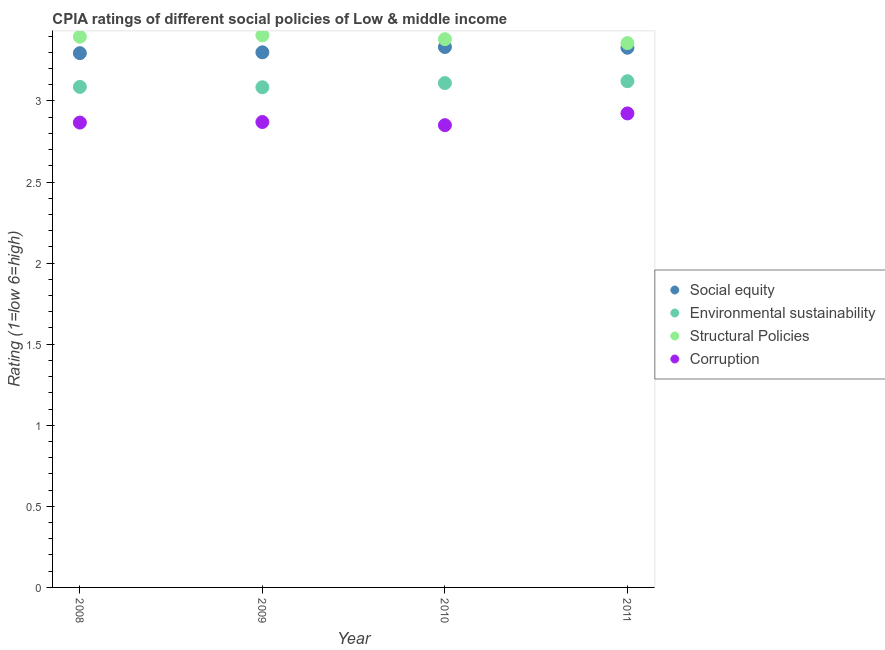How many different coloured dotlines are there?
Keep it short and to the point. 4. What is the cpia rating of corruption in 2009?
Provide a short and direct response. 2.87. Across all years, what is the maximum cpia rating of environmental sustainability?
Provide a succinct answer. 3.12. Across all years, what is the minimum cpia rating of corruption?
Keep it short and to the point. 2.85. What is the total cpia rating of structural policies in the graph?
Your answer should be compact. 13.54. What is the difference between the cpia rating of structural policies in 2009 and that in 2011?
Keep it short and to the point. 0.05. What is the difference between the cpia rating of environmental sustainability in 2010 and the cpia rating of corruption in 2008?
Your response must be concise. 0.24. What is the average cpia rating of structural policies per year?
Give a very brief answer. 3.38. In the year 2008, what is the difference between the cpia rating of structural policies and cpia rating of corruption?
Offer a very short reply. 0.53. What is the ratio of the cpia rating of social equity in 2010 to that in 2011?
Ensure brevity in your answer.  1. Is the cpia rating of social equity in 2009 less than that in 2011?
Your answer should be very brief. Yes. Is the difference between the cpia rating of structural policies in 2008 and 2011 greater than the difference between the cpia rating of social equity in 2008 and 2011?
Your answer should be compact. Yes. What is the difference between the highest and the second highest cpia rating of environmental sustainability?
Offer a very short reply. 0.01. What is the difference between the highest and the lowest cpia rating of environmental sustainability?
Provide a short and direct response. 0.04. Does the cpia rating of structural policies monotonically increase over the years?
Offer a terse response. No. Is the cpia rating of social equity strictly greater than the cpia rating of structural policies over the years?
Give a very brief answer. No. Is the cpia rating of structural policies strictly less than the cpia rating of corruption over the years?
Make the answer very short. No. How many dotlines are there?
Keep it short and to the point. 4. How many years are there in the graph?
Your response must be concise. 4. Are the values on the major ticks of Y-axis written in scientific E-notation?
Offer a very short reply. No. How are the legend labels stacked?
Give a very brief answer. Vertical. What is the title of the graph?
Ensure brevity in your answer.  CPIA ratings of different social policies of Low & middle income. Does "Revenue mobilization" appear as one of the legend labels in the graph?
Offer a terse response. No. What is the Rating (1=low 6=high) of Social equity in 2008?
Provide a succinct answer. 3.29. What is the Rating (1=low 6=high) of Environmental sustainability in 2008?
Provide a succinct answer. 3.09. What is the Rating (1=low 6=high) in Structural Policies in 2008?
Provide a short and direct response. 3.4. What is the Rating (1=low 6=high) of Corruption in 2008?
Keep it short and to the point. 2.87. What is the Rating (1=low 6=high) in Environmental sustainability in 2009?
Make the answer very short. 3.08. What is the Rating (1=low 6=high) in Structural Policies in 2009?
Offer a terse response. 3.4. What is the Rating (1=low 6=high) in Corruption in 2009?
Offer a terse response. 2.87. What is the Rating (1=low 6=high) in Social equity in 2010?
Offer a very short reply. 3.33. What is the Rating (1=low 6=high) of Environmental sustainability in 2010?
Offer a terse response. 3.11. What is the Rating (1=low 6=high) of Structural Policies in 2010?
Keep it short and to the point. 3.38. What is the Rating (1=low 6=high) in Corruption in 2010?
Your response must be concise. 2.85. What is the Rating (1=low 6=high) in Social equity in 2011?
Provide a short and direct response. 3.33. What is the Rating (1=low 6=high) of Environmental sustainability in 2011?
Your answer should be very brief. 3.12. What is the Rating (1=low 6=high) of Structural Policies in 2011?
Provide a short and direct response. 3.36. What is the Rating (1=low 6=high) of Corruption in 2011?
Offer a very short reply. 2.92. Across all years, what is the maximum Rating (1=low 6=high) in Social equity?
Keep it short and to the point. 3.33. Across all years, what is the maximum Rating (1=low 6=high) of Environmental sustainability?
Your answer should be very brief. 3.12. Across all years, what is the maximum Rating (1=low 6=high) in Structural Policies?
Your answer should be very brief. 3.4. Across all years, what is the maximum Rating (1=low 6=high) in Corruption?
Offer a very short reply. 2.92. Across all years, what is the minimum Rating (1=low 6=high) in Social equity?
Offer a very short reply. 3.29. Across all years, what is the minimum Rating (1=low 6=high) in Environmental sustainability?
Offer a terse response. 3.08. Across all years, what is the minimum Rating (1=low 6=high) in Structural Policies?
Make the answer very short. 3.36. Across all years, what is the minimum Rating (1=low 6=high) in Corruption?
Offer a terse response. 2.85. What is the total Rating (1=low 6=high) of Social equity in the graph?
Offer a terse response. 13.26. What is the total Rating (1=low 6=high) of Environmental sustainability in the graph?
Your answer should be compact. 12.4. What is the total Rating (1=low 6=high) of Structural Policies in the graph?
Make the answer very short. 13.54. What is the total Rating (1=low 6=high) of Corruption in the graph?
Provide a succinct answer. 11.51. What is the difference between the Rating (1=low 6=high) of Social equity in 2008 and that in 2009?
Give a very brief answer. -0.01. What is the difference between the Rating (1=low 6=high) in Environmental sustainability in 2008 and that in 2009?
Provide a succinct answer. 0. What is the difference between the Rating (1=low 6=high) of Structural Policies in 2008 and that in 2009?
Keep it short and to the point. -0.01. What is the difference between the Rating (1=low 6=high) in Corruption in 2008 and that in 2009?
Your answer should be very brief. -0. What is the difference between the Rating (1=low 6=high) of Social equity in 2008 and that in 2010?
Offer a terse response. -0.04. What is the difference between the Rating (1=low 6=high) of Environmental sustainability in 2008 and that in 2010?
Your response must be concise. -0.02. What is the difference between the Rating (1=low 6=high) in Structural Policies in 2008 and that in 2010?
Make the answer very short. 0.01. What is the difference between the Rating (1=low 6=high) in Corruption in 2008 and that in 2010?
Provide a short and direct response. 0.02. What is the difference between the Rating (1=low 6=high) of Social equity in 2008 and that in 2011?
Offer a terse response. -0.03. What is the difference between the Rating (1=low 6=high) of Environmental sustainability in 2008 and that in 2011?
Your response must be concise. -0.04. What is the difference between the Rating (1=low 6=high) in Structural Policies in 2008 and that in 2011?
Provide a short and direct response. 0.04. What is the difference between the Rating (1=low 6=high) in Corruption in 2008 and that in 2011?
Ensure brevity in your answer.  -0.06. What is the difference between the Rating (1=low 6=high) in Social equity in 2009 and that in 2010?
Your answer should be very brief. -0.03. What is the difference between the Rating (1=low 6=high) of Environmental sustainability in 2009 and that in 2010?
Ensure brevity in your answer.  -0.03. What is the difference between the Rating (1=low 6=high) in Structural Policies in 2009 and that in 2010?
Offer a very short reply. 0.02. What is the difference between the Rating (1=low 6=high) in Corruption in 2009 and that in 2010?
Ensure brevity in your answer.  0.02. What is the difference between the Rating (1=low 6=high) of Social equity in 2009 and that in 2011?
Keep it short and to the point. -0.03. What is the difference between the Rating (1=low 6=high) in Environmental sustainability in 2009 and that in 2011?
Keep it short and to the point. -0.04. What is the difference between the Rating (1=low 6=high) of Structural Policies in 2009 and that in 2011?
Give a very brief answer. 0.05. What is the difference between the Rating (1=low 6=high) in Corruption in 2009 and that in 2011?
Your answer should be very brief. -0.05. What is the difference between the Rating (1=low 6=high) of Social equity in 2010 and that in 2011?
Your answer should be very brief. 0. What is the difference between the Rating (1=low 6=high) of Environmental sustainability in 2010 and that in 2011?
Offer a terse response. -0.01. What is the difference between the Rating (1=low 6=high) in Structural Policies in 2010 and that in 2011?
Provide a short and direct response. 0.02. What is the difference between the Rating (1=low 6=high) of Corruption in 2010 and that in 2011?
Offer a very short reply. -0.07. What is the difference between the Rating (1=low 6=high) in Social equity in 2008 and the Rating (1=low 6=high) in Environmental sustainability in 2009?
Keep it short and to the point. 0.21. What is the difference between the Rating (1=low 6=high) in Social equity in 2008 and the Rating (1=low 6=high) in Structural Policies in 2009?
Your answer should be very brief. -0.11. What is the difference between the Rating (1=low 6=high) in Social equity in 2008 and the Rating (1=low 6=high) in Corruption in 2009?
Make the answer very short. 0.42. What is the difference between the Rating (1=low 6=high) in Environmental sustainability in 2008 and the Rating (1=low 6=high) in Structural Policies in 2009?
Your answer should be very brief. -0.32. What is the difference between the Rating (1=low 6=high) in Environmental sustainability in 2008 and the Rating (1=low 6=high) in Corruption in 2009?
Provide a succinct answer. 0.22. What is the difference between the Rating (1=low 6=high) in Structural Policies in 2008 and the Rating (1=low 6=high) in Corruption in 2009?
Provide a succinct answer. 0.53. What is the difference between the Rating (1=low 6=high) in Social equity in 2008 and the Rating (1=low 6=high) in Environmental sustainability in 2010?
Ensure brevity in your answer.  0.18. What is the difference between the Rating (1=low 6=high) of Social equity in 2008 and the Rating (1=low 6=high) of Structural Policies in 2010?
Give a very brief answer. -0.09. What is the difference between the Rating (1=low 6=high) in Social equity in 2008 and the Rating (1=low 6=high) in Corruption in 2010?
Offer a terse response. 0.44. What is the difference between the Rating (1=low 6=high) of Environmental sustainability in 2008 and the Rating (1=low 6=high) of Structural Policies in 2010?
Keep it short and to the point. -0.29. What is the difference between the Rating (1=low 6=high) of Environmental sustainability in 2008 and the Rating (1=low 6=high) of Corruption in 2010?
Give a very brief answer. 0.24. What is the difference between the Rating (1=low 6=high) of Structural Policies in 2008 and the Rating (1=low 6=high) of Corruption in 2010?
Keep it short and to the point. 0.55. What is the difference between the Rating (1=low 6=high) of Social equity in 2008 and the Rating (1=low 6=high) of Environmental sustainability in 2011?
Offer a terse response. 0.17. What is the difference between the Rating (1=low 6=high) of Social equity in 2008 and the Rating (1=low 6=high) of Structural Policies in 2011?
Keep it short and to the point. -0.06. What is the difference between the Rating (1=low 6=high) in Social equity in 2008 and the Rating (1=low 6=high) in Corruption in 2011?
Offer a very short reply. 0.37. What is the difference between the Rating (1=low 6=high) in Environmental sustainability in 2008 and the Rating (1=low 6=high) in Structural Policies in 2011?
Provide a short and direct response. -0.27. What is the difference between the Rating (1=low 6=high) in Environmental sustainability in 2008 and the Rating (1=low 6=high) in Corruption in 2011?
Offer a terse response. 0.16. What is the difference between the Rating (1=low 6=high) in Structural Policies in 2008 and the Rating (1=low 6=high) in Corruption in 2011?
Offer a very short reply. 0.47. What is the difference between the Rating (1=low 6=high) of Social equity in 2009 and the Rating (1=low 6=high) of Environmental sustainability in 2010?
Your response must be concise. 0.19. What is the difference between the Rating (1=low 6=high) of Social equity in 2009 and the Rating (1=low 6=high) of Structural Policies in 2010?
Provide a short and direct response. -0.08. What is the difference between the Rating (1=low 6=high) of Social equity in 2009 and the Rating (1=low 6=high) of Corruption in 2010?
Ensure brevity in your answer.  0.45. What is the difference between the Rating (1=low 6=high) of Environmental sustainability in 2009 and the Rating (1=low 6=high) of Structural Policies in 2010?
Provide a succinct answer. -0.3. What is the difference between the Rating (1=low 6=high) of Environmental sustainability in 2009 and the Rating (1=low 6=high) of Corruption in 2010?
Keep it short and to the point. 0.23. What is the difference between the Rating (1=low 6=high) of Structural Policies in 2009 and the Rating (1=low 6=high) of Corruption in 2010?
Offer a terse response. 0.55. What is the difference between the Rating (1=low 6=high) in Social equity in 2009 and the Rating (1=low 6=high) in Environmental sustainability in 2011?
Your answer should be very brief. 0.18. What is the difference between the Rating (1=low 6=high) of Social equity in 2009 and the Rating (1=low 6=high) of Structural Policies in 2011?
Offer a very short reply. -0.06. What is the difference between the Rating (1=low 6=high) in Social equity in 2009 and the Rating (1=low 6=high) in Corruption in 2011?
Provide a short and direct response. 0.38. What is the difference between the Rating (1=low 6=high) of Environmental sustainability in 2009 and the Rating (1=low 6=high) of Structural Policies in 2011?
Your answer should be very brief. -0.27. What is the difference between the Rating (1=low 6=high) in Environmental sustainability in 2009 and the Rating (1=low 6=high) in Corruption in 2011?
Keep it short and to the point. 0.16. What is the difference between the Rating (1=low 6=high) of Structural Policies in 2009 and the Rating (1=low 6=high) of Corruption in 2011?
Ensure brevity in your answer.  0.48. What is the difference between the Rating (1=low 6=high) of Social equity in 2010 and the Rating (1=low 6=high) of Environmental sustainability in 2011?
Keep it short and to the point. 0.21. What is the difference between the Rating (1=low 6=high) in Social equity in 2010 and the Rating (1=low 6=high) in Structural Policies in 2011?
Your answer should be very brief. -0.02. What is the difference between the Rating (1=low 6=high) of Social equity in 2010 and the Rating (1=low 6=high) of Corruption in 2011?
Your answer should be compact. 0.41. What is the difference between the Rating (1=low 6=high) of Environmental sustainability in 2010 and the Rating (1=low 6=high) of Structural Policies in 2011?
Make the answer very short. -0.25. What is the difference between the Rating (1=low 6=high) of Environmental sustainability in 2010 and the Rating (1=low 6=high) of Corruption in 2011?
Your answer should be compact. 0.19. What is the difference between the Rating (1=low 6=high) of Structural Policies in 2010 and the Rating (1=low 6=high) of Corruption in 2011?
Offer a very short reply. 0.46. What is the average Rating (1=low 6=high) in Social equity per year?
Give a very brief answer. 3.31. What is the average Rating (1=low 6=high) in Environmental sustainability per year?
Provide a succinct answer. 3.1. What is the average Rating (1=low 6=high) in Structural Policies per year?
Offer a very short reply. 3.38. What is the average Rating (1=low 6=high) in Corruption per year?
Make the answer very short. 2.88. In the year 2008, what is the difference between the Rating (1=low 6=high) of Social equity and Rating (1=low 6=high) of Environmental sustainability?
Provide a short and direct response. 0.21. In the year 2008, what is the difference between the Rating (1=low 6=high) in Social equity and Rating (1=low 6=high) in Structural Policies?
Your answer should be very brief. -0.1. In the year 2008, what is the difference between the Rating (1=low 6=high) in Social equity and Rating (1=low 6=high) in Corruption?
Keep it short and to the point. 0.43. In the year 2008, what is the difference between the Rating (1=low 6=high) in Environmental sustainability and Rating (1=low 6=high) in Structural Policies?
Keep it short and to the point. -0.31. In the year 2008, what is the difference between the Rating (1=low 6=high) of Environmental sustainability and Rating (1=low 6=high) of Corruption?
Your answer should be compact. 0.22. In the year 2008, what is the difference between the Rating (1=low 6=high) of Structural Policies and Rating (1=low 6=high) of Corruption?
Provide a succinct answer. 0.53. In the year 2009, what is the difference between the Rating (1=low 6=high) in Social equity and Rating (1=low 6=high) in Environmental sustainability?
Keep it short and to the point. 0.22. In the year 2009, what is the difference between the Rating (1=low 6=high) of Social equity and Rating (1=low 6=high) of Structural Policies?
Make the answer very short. -0.1. In the year 2009, what is the difference between the Rating (1=low 6=high) of Social equity and Rating (1=low 6=high) of Corruption?
Your answer should be very brief. 0.43. In the year 2009, what is the difference between the Rating (1=low 6=high) of Environmental sustainability and Rating (1=low 6=high) of Structural Policies?
Your response must be concise. -0.32. In the year 2009, what is the difference between the Rating (1=low 6=high) of Environmental sustainability and Rating (1=low 6=high) of Corruption?
Provide a short and direct response. 0.21. In the year 2009, what is the difference between the Rating (1=low 6=high) in Structural Policies and Rating (1=low 6=high) in Corruption?
Offer a very short reply. 0.53. In the year 2010, what is the difference between the Rating (1=low 6=high) of Social equity and Rating (1=low 6=high) of Environmental sustainability?
Give a very brief answer. 0.22. In the year 2010, what is the difference between the Rating (1=low 6=high) in Social equity and Rating (1=low 6=high) in Structural Policies?
Keep it short and to the point. -0.05. In the year 2010, what is the difference between the Rating (1=low 6=high) of Social equity and Rating (1=low 6=high) of Corruption?
Your answer should be compact. 0.48. In the year 2010, what is the difference between the Rating (1=low 6=high) of Environmental sustainability and Rating (1=low 6=high) of Structural Policies?
Your answer should be very brief. -0.27. In the year 2010, what is the difference between the Rating (1=low 6=high) of Environmental sustainability and Rating (1=low 6=high) of Corruption?
Give a very brief answer. 0.26. In the year 2010, what is the difference between the Rating (1=low 6=high) in Structural Policies and Rating (1=low 6=high) in Corruption?
Provide a short and direct response. 0.53. In the year 2011, what is the difference between the Rating (1=low 6=high) in Social equity and Rating (1=low 6=high) in Environmental sustainability?
Your answer should be compact. 0.21. In the year 2011, what is the difference between the Rating (1=low 6=high) of Social equity and Rating (1=low 6=high) of Structural Policies?
Provide a succinct answer. -0.03. In the year 2011, what is the difference between the Rating (1=low 6=high) in Social equity and Rating (1=low 6=high) in Corruption?
Make the answer very short. 0.41. In the year 2011, what is the difference between the Rating (1=low 6=high) of Environmental sustainability and Rating (1=low 6=high) of Structural Policies?
Provide a short and direct response. -0.23. In the year 2011, what is the difference between the Rating (1=low 6=high) of Environmental sustainability and Rating (1=low 6=high) of Corruption?
Keep it short and to the point. 0.2. In the year 2011, what is the difference between the Rating (1=low 6=high) of Structural Policies and Rating (1=low 6=high) of Corruption?
Offer a terse response. 0.43. What is the ratio of the Rating (1=low 6=high) of Structural Policies in 2008 to that in 2009?
Offer a terse response. 1. What is the ratio of the Rating (1=low 6=high) of Corruption in 2008 to that in 2009?
Make the answer very short. 1. What is the ratio of the Rating (1=low 6=high) in Social equity in 2008 to that in 2010?
Offer a terse response. 0.99. What is the ratio of the Rating (1=low 6=high) in Structural Policies in 2008 to that in 2010?
Your answer should be compact. 1. What is the ratio of the Rating (1=low 6=high) of Corruption in 2008 to that in 2010?
Your answer should be very brief. 1.01. What is the ratio of the Rating (1=low 6=high) in Social equity in 2008 to that in 2011?
Offer a very short reply. 0.99. What is the ratio of the Rating (1=low 6=high) of Environmental sustainability in 2008 to that in 2011?
Provide a succinct answer. 0.99. What is the ratio of the Rating (1=low 6=high) in Structural Policies in 2008 to that in 2011?
Your response must be concise. 1.01. What is the ratio of the Rating (1=low 6=high) in Corruption in 2008 to that in 2011?
Offer a very short reply. 0.98. What is the ratio of the Rating (1=low 6=high) of Social equity in 2009 to that in 2010?
Offer a very short reply. 0.99. What is the ratio of the Rating (1=low 6=high) of Environmental sustainability in 2009 to that in 2010?
Provide a short and direct response. 0.99. What is the ratio of the Rating (1=low 6=high) of Corruption in 2009 to that in 2010?
Offer a very short reply. 1.01. What is the ratio of the Rating (1=low 6=high) of Structural Policies in 2009 to that in 2011?
Give a very brief answer. 1.01. What is the ratio of the Rating (1=low 6=high) of Corruption in 2009 to that in 2011?
Your response must be concise. 0.98. What is the ratio of the Rating (1=low 6=high) in Environmental sustainability in 2010 to that in 2011?
Offer a terse response. 1. What is the ratio of the Rating (1=low 6=high) of Structural Policies in 2010 to that in 2011?
Keep it short and to the point. 1.01. What is the ratio of the Rating (1=low 6=high) in Corruption in 2010 to that in 2011?
Your response must be concise. 0.98. What is the difference between the highest and the second highest Rating (1=low 6=high) of Social equity?
Provide a short and direct response. 0. What is the difference between the highest and the second highest Rating (1=low 6=high) of Environmental sustainability?
Your answer should be compact. 0.01. What is the difference between the highest and the second highest Rating (1=low 6=high) of Structural Policies?
Offer a very short reply. 0.01. What is the difference between the highest and the second highest Rating (1=low 6=high) in Corruption?
Ensure brevity in your answer.  0.05. What is the difference between the highest and the lowest Rating (1=low 6=high) of Social equity?
Ensure brevity in your answer.  0.04. What is the difference between the highest and the lowest Rating (1=low 6=high) in Environmental sustainability?
Provide a succinct answer. 0.04. What is the difference between the highest and the lowest Rating (1=low 6=high) in Structural Policies?
Your answer should be very brief. 0.05. What is the difference between the highest and the lowest Rating (1=low 6=high) of Corruption?
Ensure brevity in your answer.  0.07. 